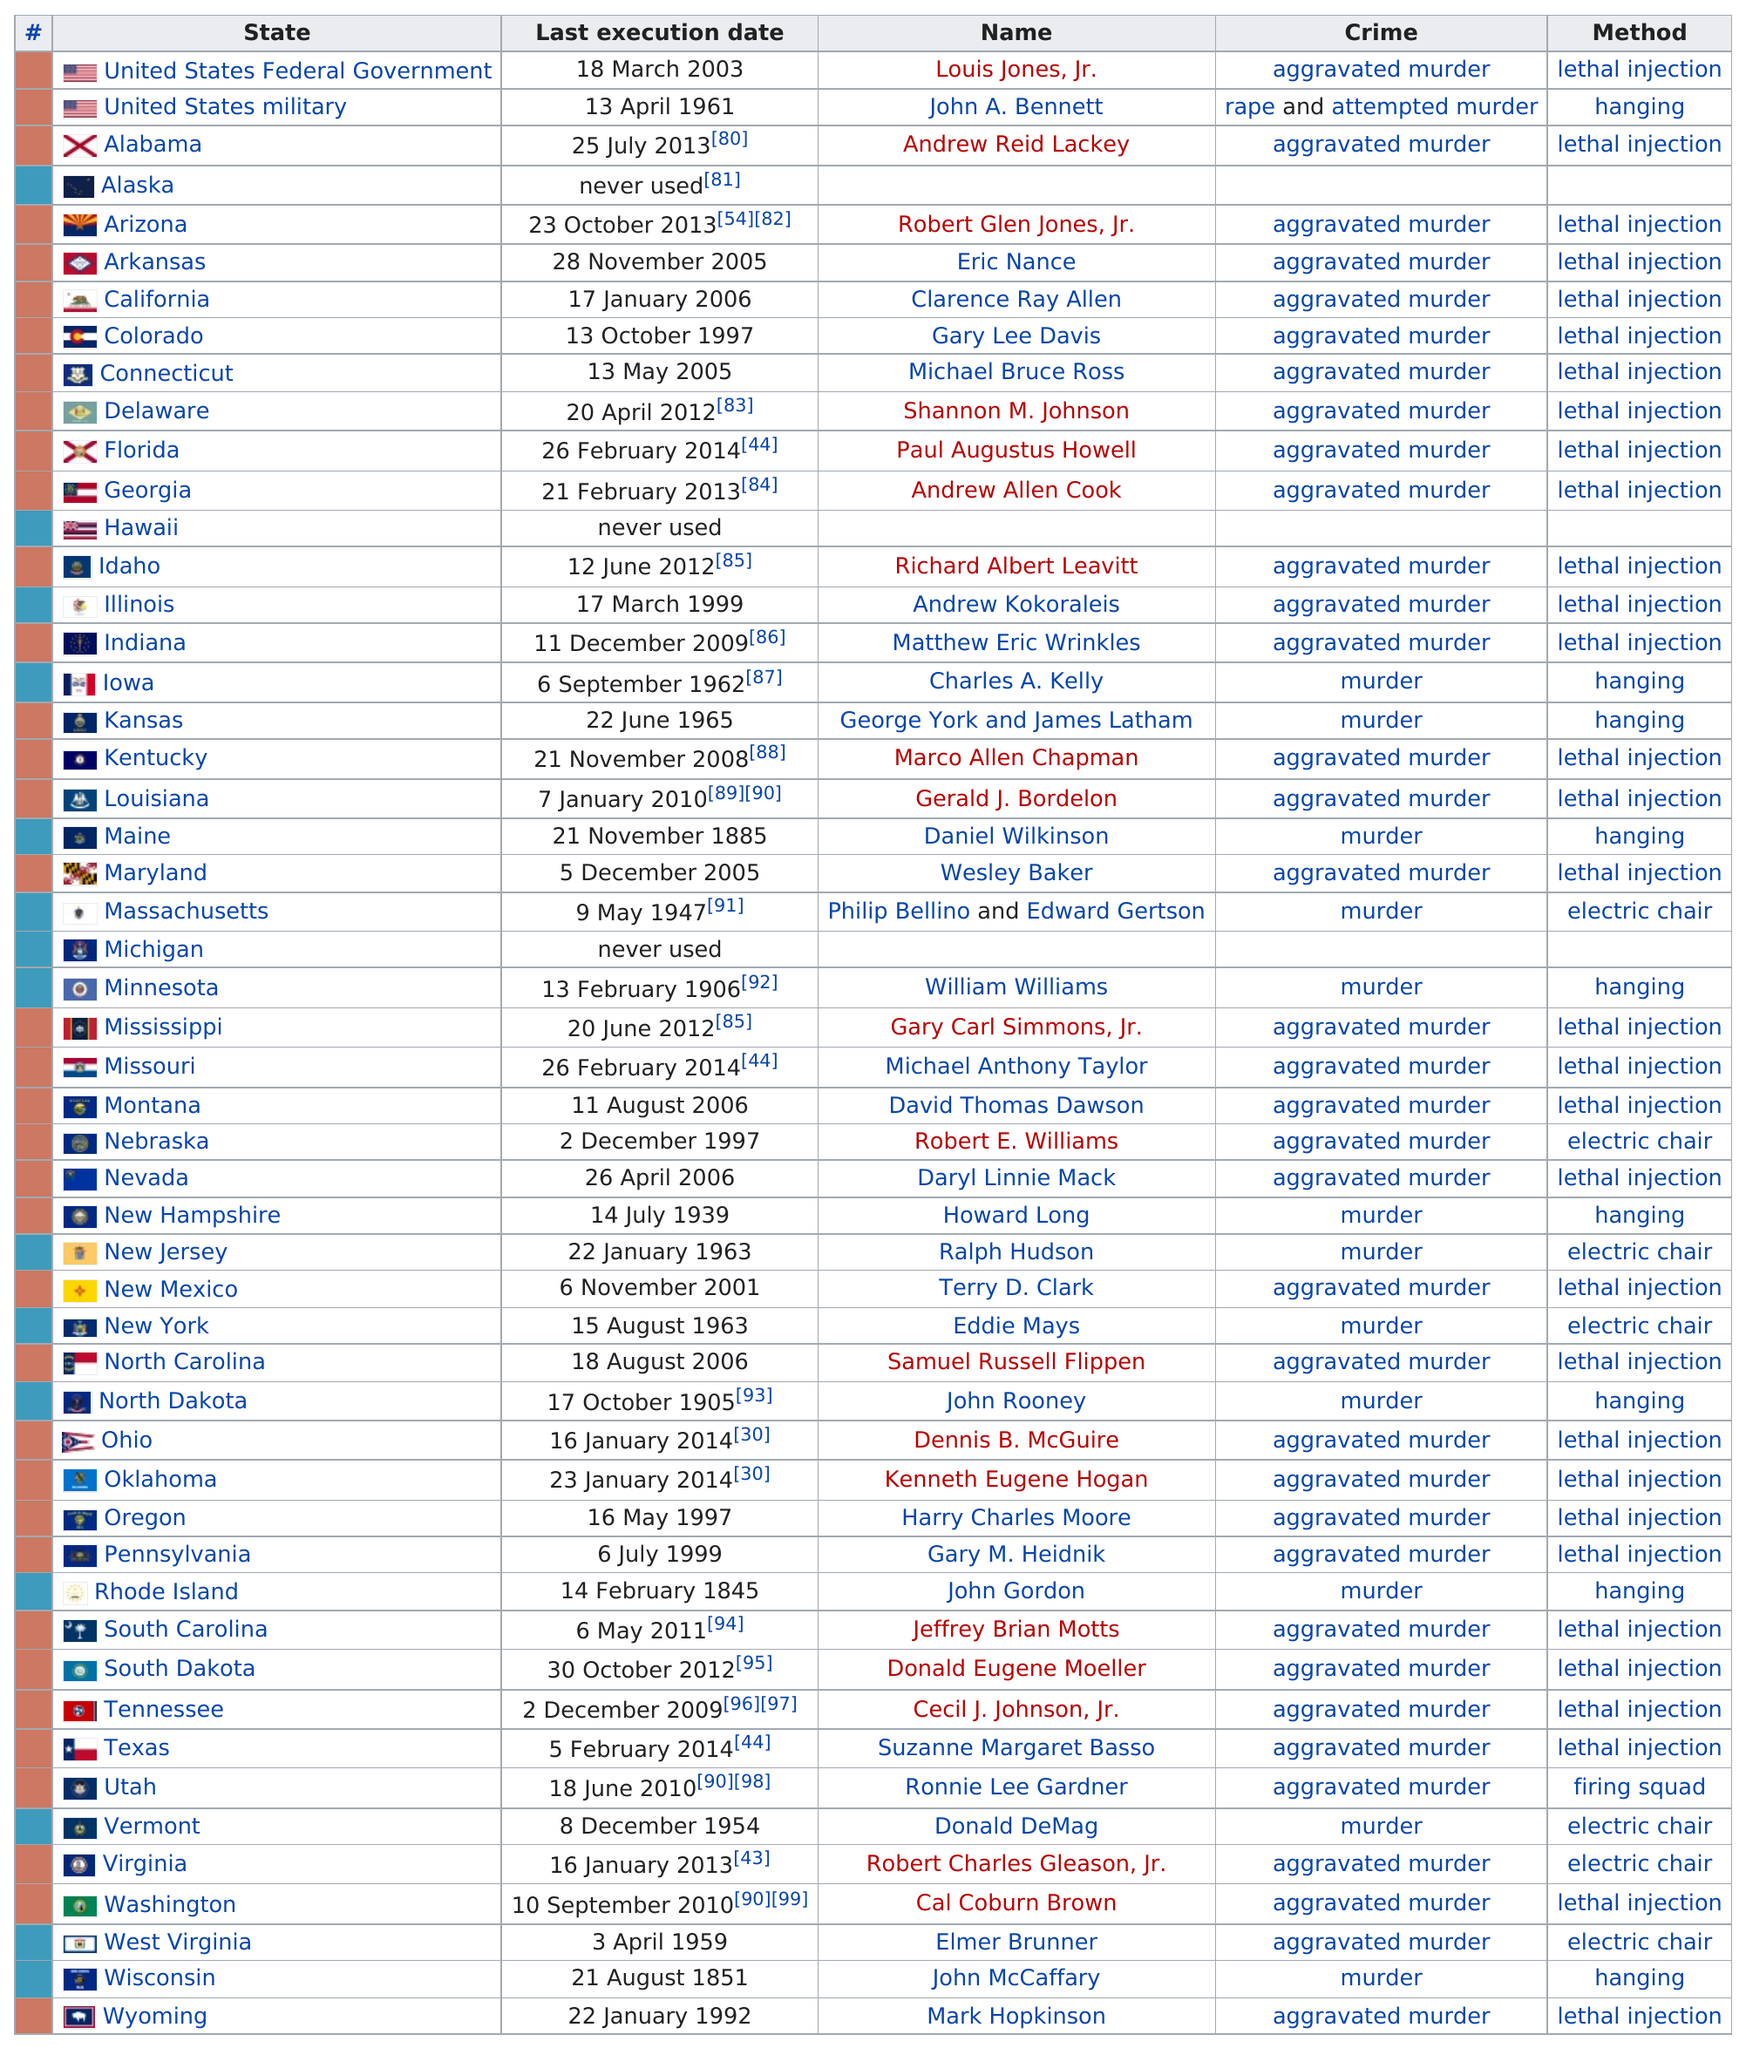Indicate a few pertinent items in this graphic. There are three states that have not executed any individuals. In December of 2005, the state of Maryland carried out an execution using the method of lethal injection. Thirty-one states had their last execution take place in 1997 or earlier, including Alaska, Arizona, Colorado, Connecticut, Idaho, Indiana, Iowa, Kentucky, Maine, Massachusetts, Michigan, Minnesota, Mississippi, Missouri, Montana, Nebraska, Nevada, New Hampshire, New Jersey, New Mexico, New York, North Carolina, North Dakota, Ohio, Oklahoma, Oregon, Pennsylvania, Rhode Island, South Dakota, Vermont, Washington, West Virginia, and Wyoming. The first hanging occurred 169 years ago. Eight states have used lethal injection as the method of execution in consecutive order. 